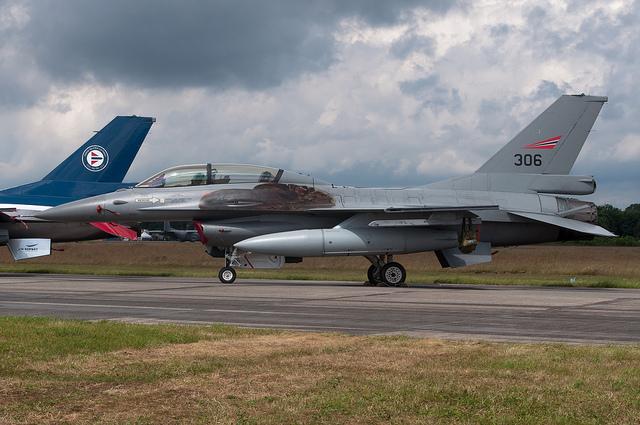What is the jet's number?
Be succinct. 306. What might the plane pictured here be used for?
Give a very brief answer. War. Where do you see this type of vehicle?
Give a very brief answer. Airport. What is the number on the closest plane?
Concise answer only. 306. Is the plane departing?
Give a very brief answer. No. 